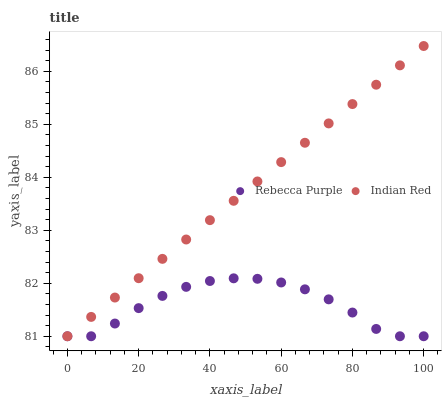Does Rebecca Purple have the minimum area under the curve?
Answer yes or no. Yes. Does Indian Red have the maximum area under the curve?
Answer yes or no. Yes. Does Indian Red have the minimum area under the curve?
Answer yes or no. No. Is Indian Red the smoothest?
Answer yes or no. Yes. Is Rebecca Purple the roughest?
Answer yes or no. Yes. Is Indian Red the roughest?
Answer yes or no. No. Does Rebecca Purple have the lowest value?
Answer yes or no. Yes. Does Indian Red have the highest value?
Answer yes or no. Yes. Does Indian Red intersect Rebecca Purple?
Answer yes or no. Yes. Is Indian Red less than Rebecca Purple?
Answer yes or no. No. Is Indian Red greater than Rebecca Purple?
Answer yes or no. No. 